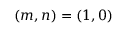<formula> <loc_0><loc_0><loc_500><loc_500>( m , n ) = ( 1 , 0 )</formula> 